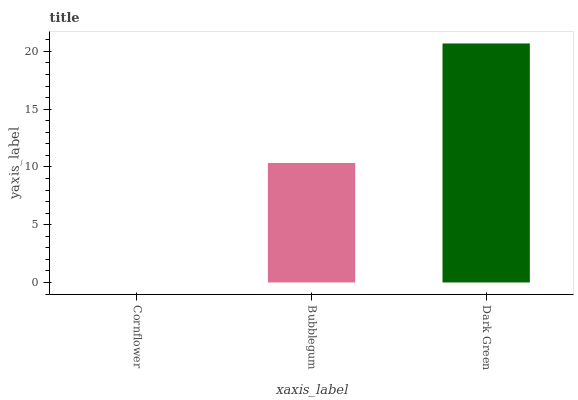Is Cornflower the minimum?
Answer yes or no. Yes. Is Dark Green the maximum?
Answer yes or no. Yes. Is Bubblegum the minimum?
Answer yes or no. No. Is Bubblegum the maximum?
Answer yes or no. No. Is Bubblegum greater than Cornflower?
Answer yes or no. Yes. Is Cornflower less than Bubblegum?
Answer yes or no. Yes. Is Cornflower greater than Bubblegum?
Answer yes or no. No. Is Bubblegum less than Cornflower?
Answer yes or no. No. Is Bubblegum the high median?
Answer yes or no. Yes. Is Bubblegum the low median?
Answer yes or no. Yes. Is Dark Green the high median?
Answer yes or no. No. Is Cornflower the low median?
Answer yes or no. No. 